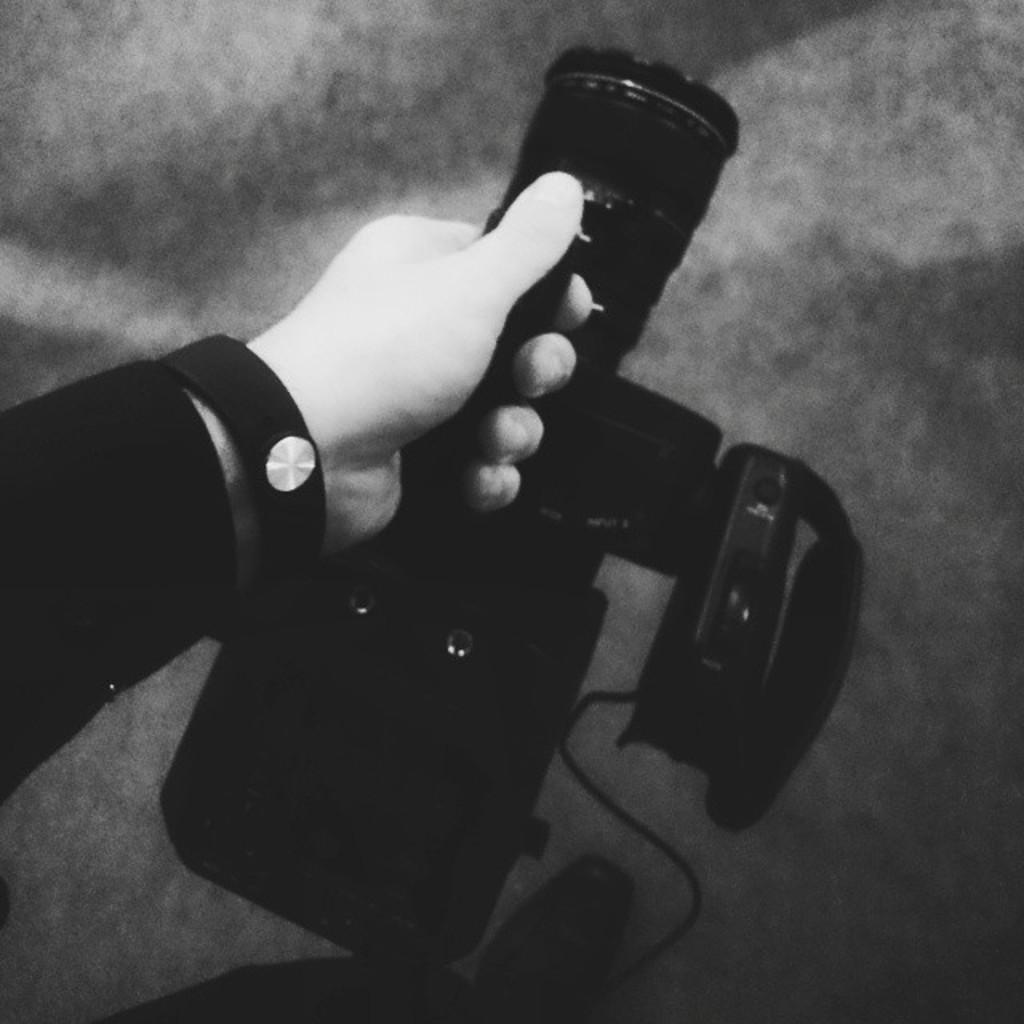What object is being held in the image? There is a video recorder in the image. How is the video recorder being held? The video recorder is being held in a hand. What type of earthquake can be seen in the image? There is no earthquake present in the image; it features a video recorder being held in a hand. Can you point out the flock of birds in the image? There are no birds or flock present in the image. 